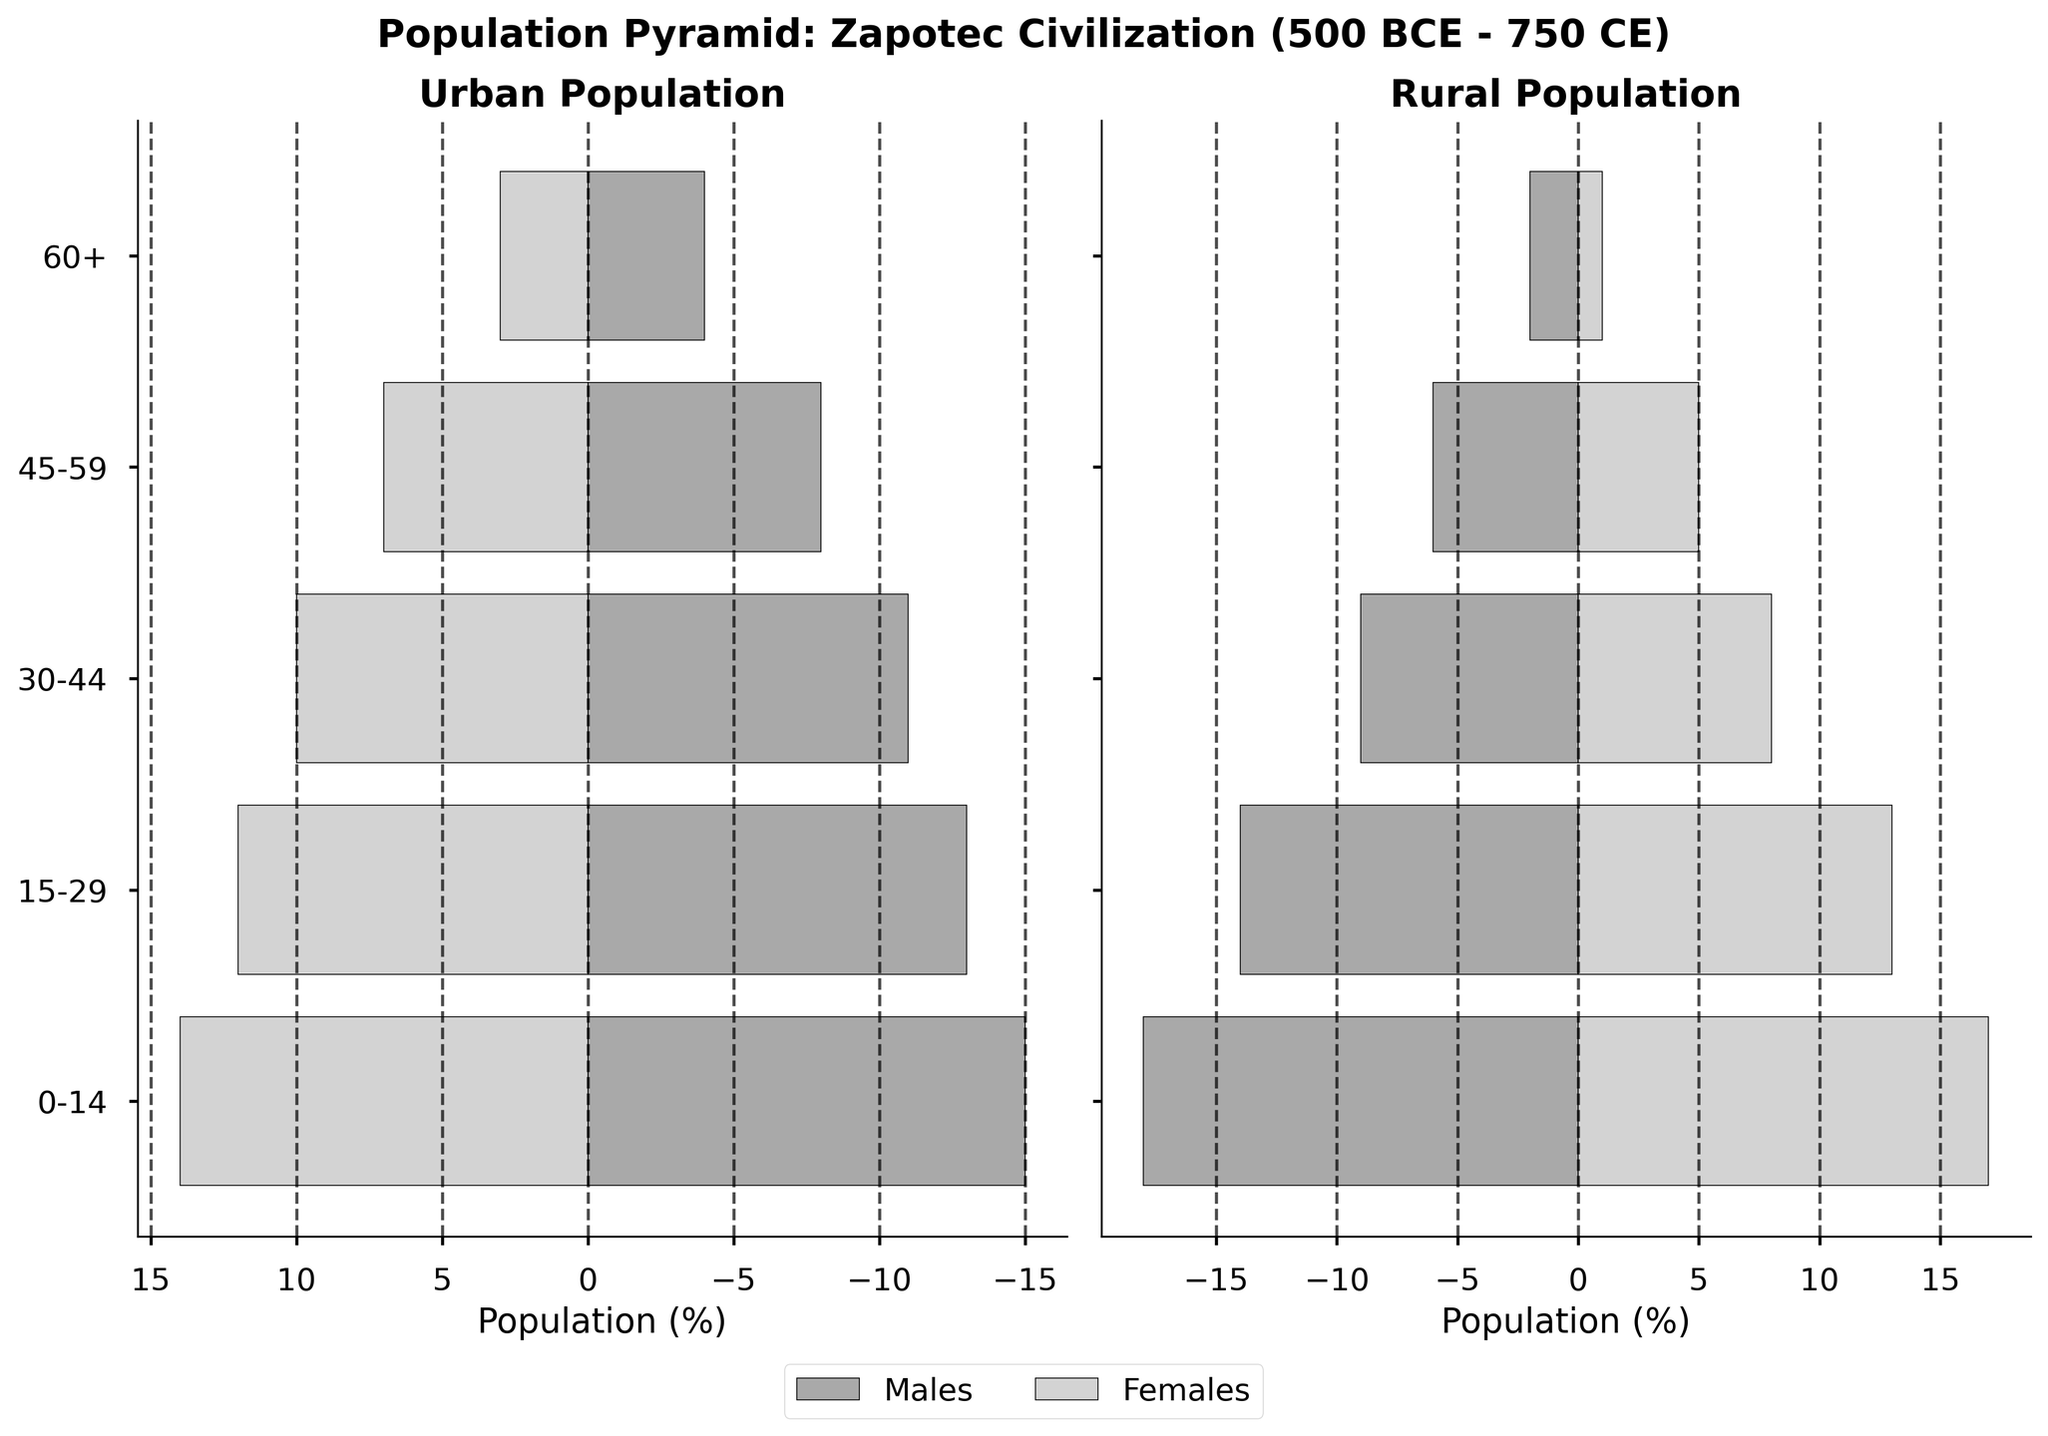How many age groups are covered in the population pyramid? There are five age groups shown on the population pyramid: 0-14, 15-29, 30-44, 45-59, and 60+.
Answer: Five Which age group has the highest population in the rural areas? By observing the rural pyramid bars, the age group 0-14 has the longest bars for both males and females, indicating the highest population.
Answer: 0-14 Are there more males or females in the urban areas within the 30-44 age group? Examining the urban section, the length of the bar for males in the 30-44 age group is slightly longer than that for females, indicating there are more males.
Answer: Males What is the total number of people in the 45-59 age group for both urban and rural populations combined? Adding up the populations, urban 45-59: (8 males + 7 females) and rural 45-59: (6 males + 5 females) results in 8+7+6+5 = 26 people.
Answer: 26 Which population has the lowest count among all groups and areas? The rural 60+ female group has the smallest bar, representing the lowest population.
Answer: Rural Females, 60+ How does the 15-29 age group in rural areas compare to the same age group in urban areas? Comparing the bars, rural males (14) and females (13) in the 15-29 age group slightly outnumber their urban counterparts (13 males, 12 females).
Answer: Rural has slightly more Is there a significant gender difference in the 0-14 age group in urban areas? Observing the urban area bars for the 0-14 age group, the difference between males (15) and females (14) is minimal.
Answer: No significant difference Which demographic, rural or urban, shows a sharper decline in population with increasing age? Comparing both plots, the rural areas exhibit a steeper decline, especially noticeable in the 60+ age group.
Answer: Rural What is the difference in the number of urban females versus rural females in the 30-44 age group? Urban females in 30-44: 10, Rural females in 30-44: 8. The difference is 10 - 8 = 2.
Answer: 2 In which population sector (urban or rural) do males consistently outnumber females across all age groups? By comparing each age group, it can be observed that in both urban and rural sectors, males outnumber females in all age groups.
Answer: Both 